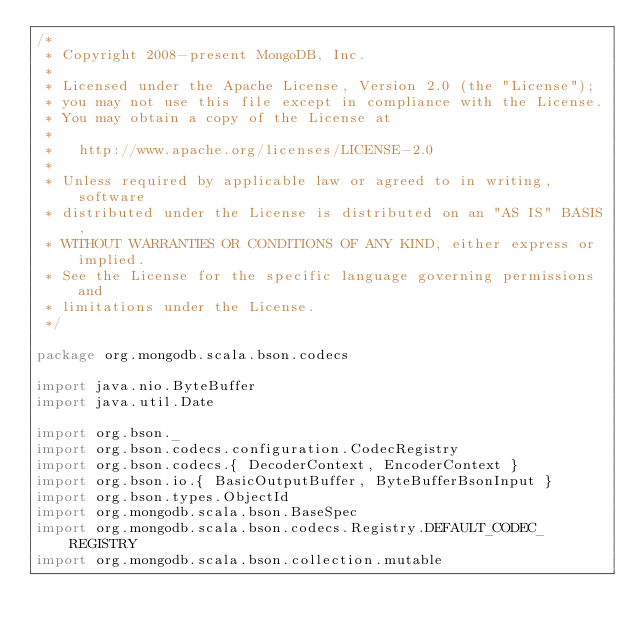<code> <loc_0><loc_0><loc_500><loc_500><_Scala_>/*
 * Copyright 2008-present MongoDB, Inc.
 *
 * Licensed under the Apache License, Version 2.0 (the "License");
 * you may not use this file except in compliance with the License.
 * You may obtain a copy of the License at
 *
 *   http://www.apache.org/licenses/LICENSE-2.0
 *
 * Unless required by applicable law or agreed to in writing, software
 * distributed under the License is distributed on an "AS IS" BASIS,
 * WITHOUT WARRANTIES OR CONDITIONS OF ANY KIND, either express or implied.
 * See the License for the specific language governing permissions and
 * limitations under the License.
 */

package org.mongodb.scala.bson.codecs

import java.nio.ByteBuffer
import java.util.Date

import org.bson._
import org.bson.codecs.configuration.CodecRegistry
import org.bson.codecs.{ DecoderContext, EncoderContext }
import org.bson.io.{ BasicOutputBuffer, ByteBufferBsonInput }
import org.bson.types.ObjectId
import org.mongodb.scala.bson.BaseSpec
import org.mongodb.scala.bson.codecs.Registry.DEFAULT_CODEC_REGISTRY
import org.mongodb.scala.bson.collection.mutable</code> 